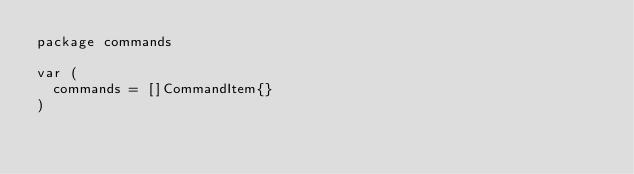<code> <loc_0><loc_0><loc_500><loc_500><_Go_>package commands

var (
	commands = []CommandItem{}
)
</code> 